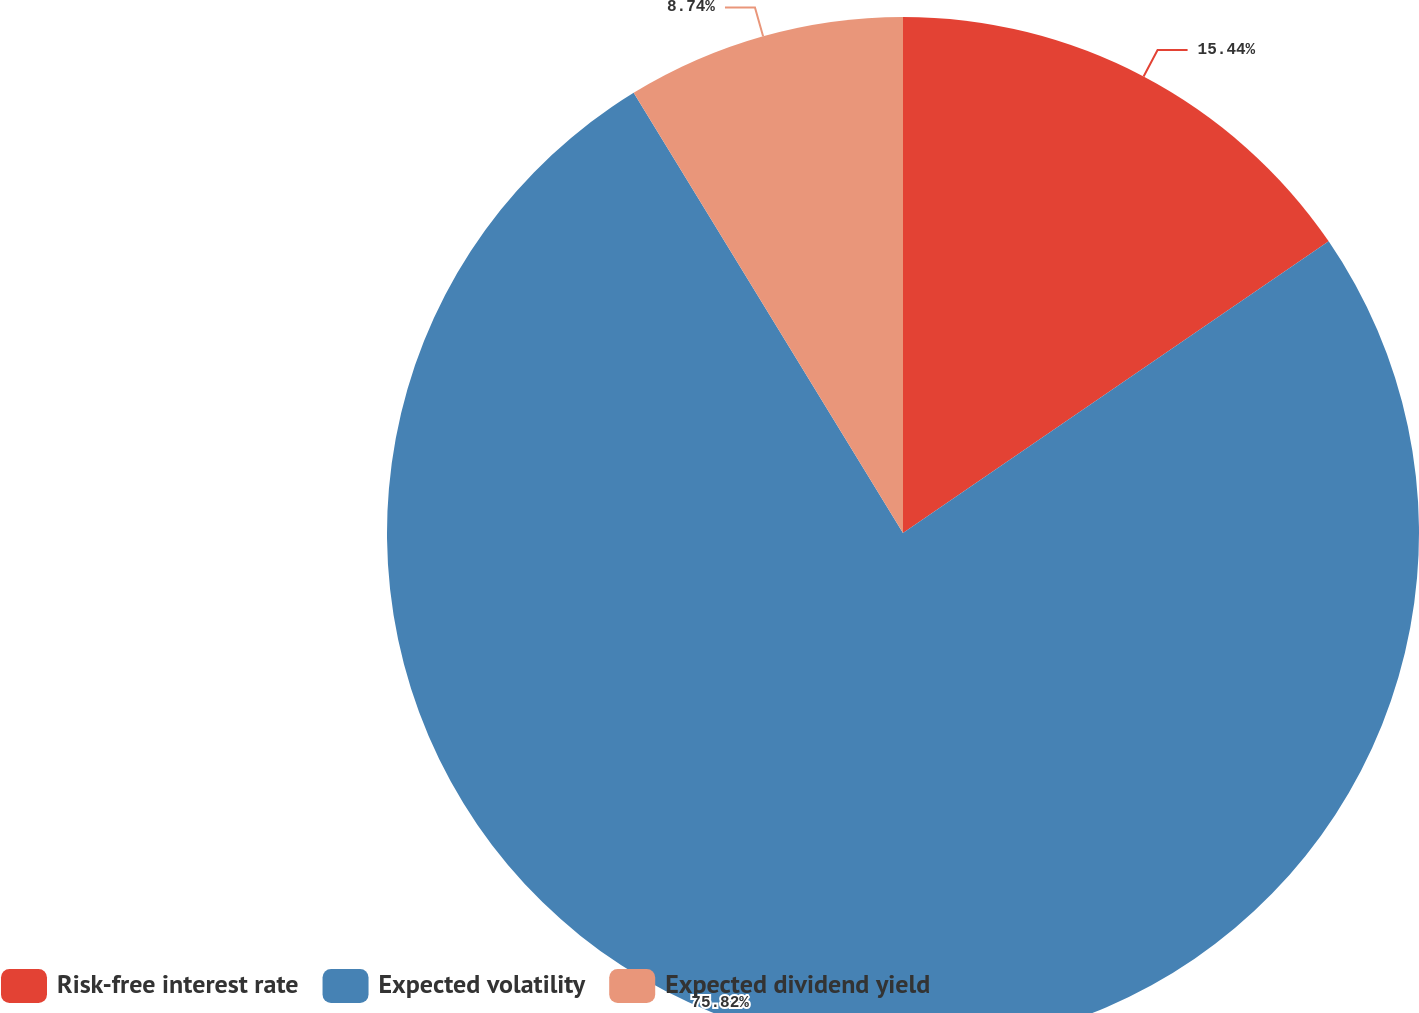<chart> <loc_0><loc_0><loc_500><loc_500><pie_chart><fcel>Risk-free interest rate<fcel>Expected volatility<fcel>Expected dividend yield<nl><fcel>15.44%<fcel>75.82%<fcel>8.74%<nl></chart> 